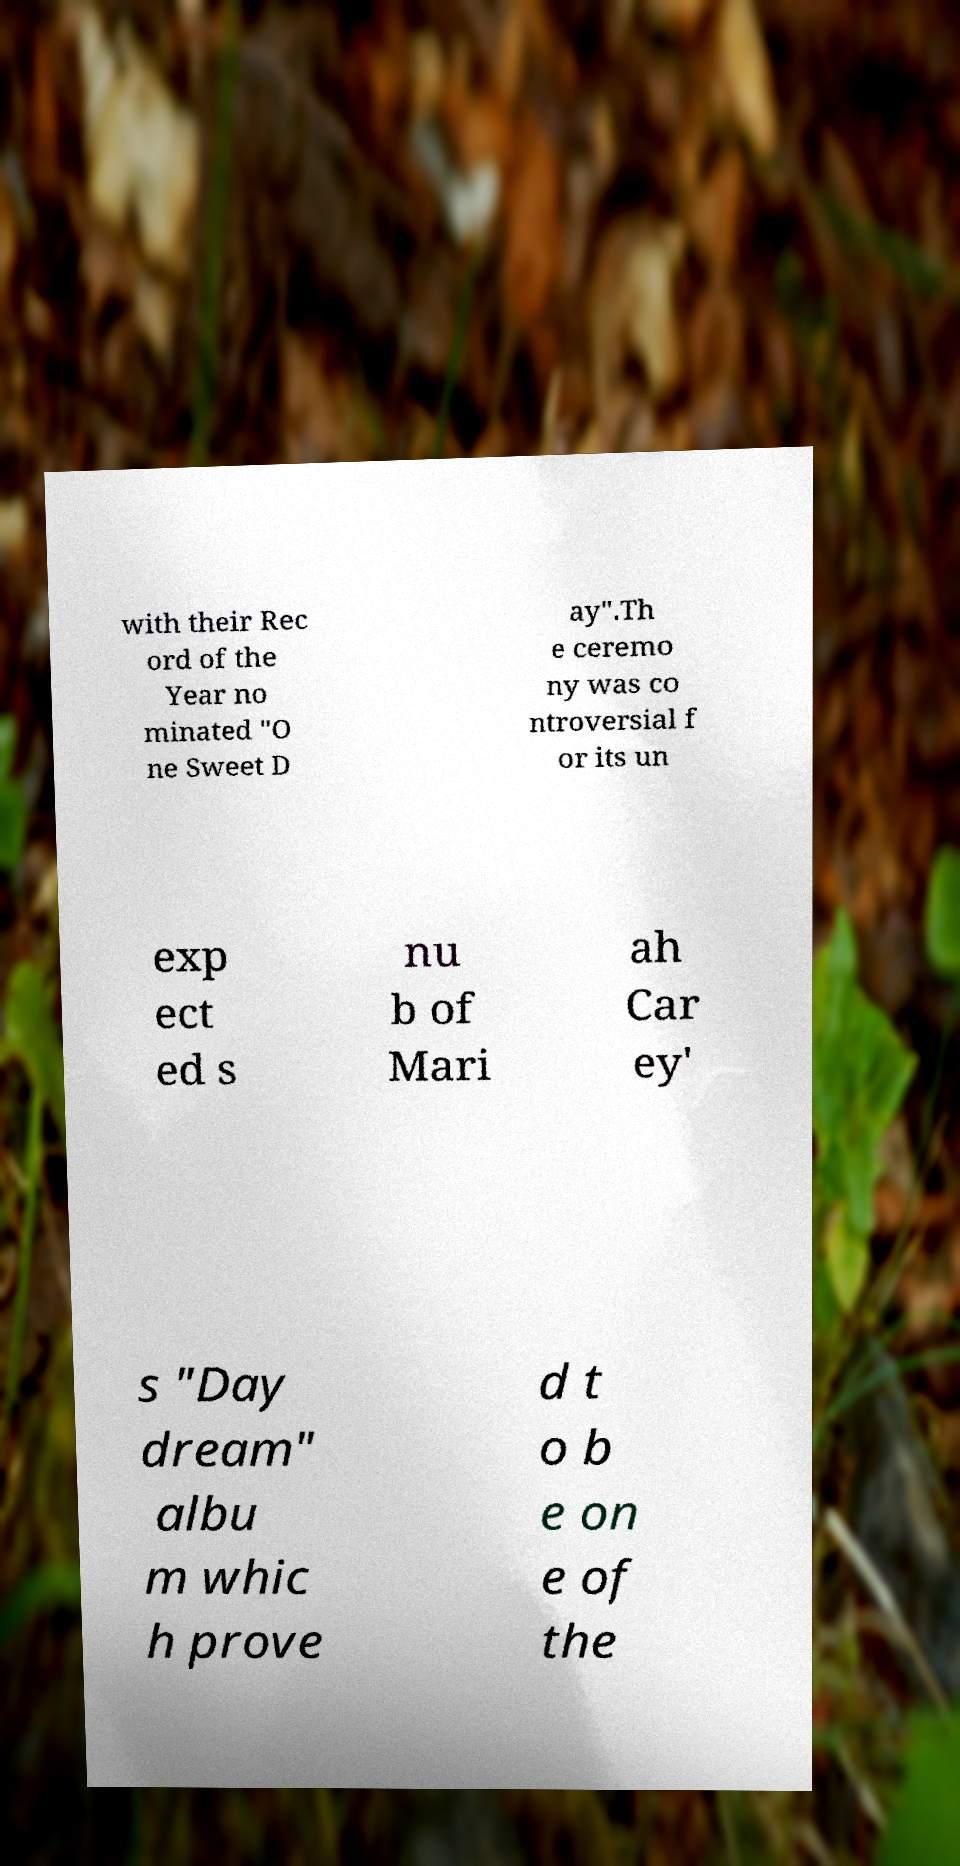Can you accurately transcribe the text from the provided image for me? with their Rec ord of the Year no minated "O ne Sweet D ay".Th e ceremo ny was co ntroversial f or its un exp ect ed s nu b of Mari ah Car ey' s "Day dream" albu m whic h prove d t o b e on e of the 